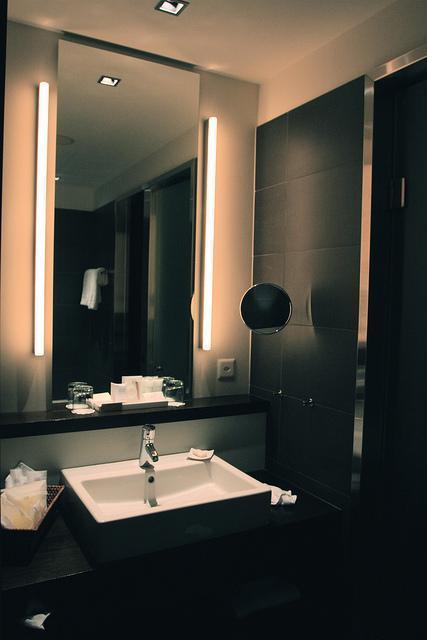How many mirrors are there?
Give a very brief answer. 1. How many of these giraffe are taller than the wires?
Give a very brief answer. 0. 